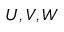Convert formula to latex. <formula><loc_0><loc_0><loc_500><loc_500>U , V , W</formula> 